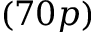Convert formula to latex. <formula><loc_0><loc_0><loc_500><loc_500>( 7 0 p )</formula> 